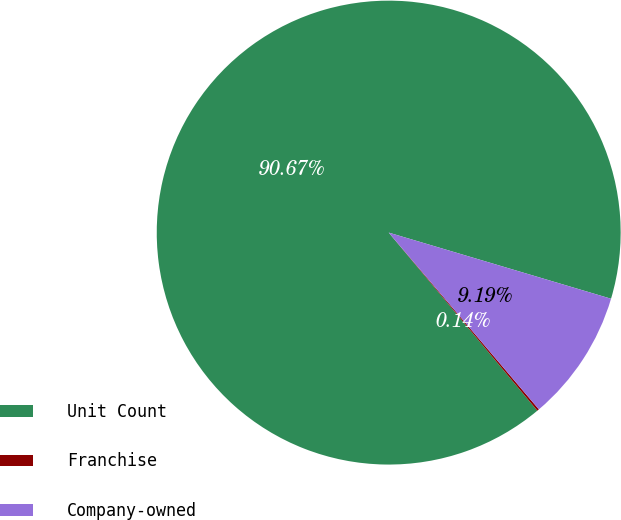<chart> <loc_0><loc_0><loc_500><loc_500><pie_chart><fcel>Unit Count<fcel>Franchise<fcel>Company-owned<nl><fcel>90.68%<fcel>0.14%<fcel>9.19%<nl></chart> 